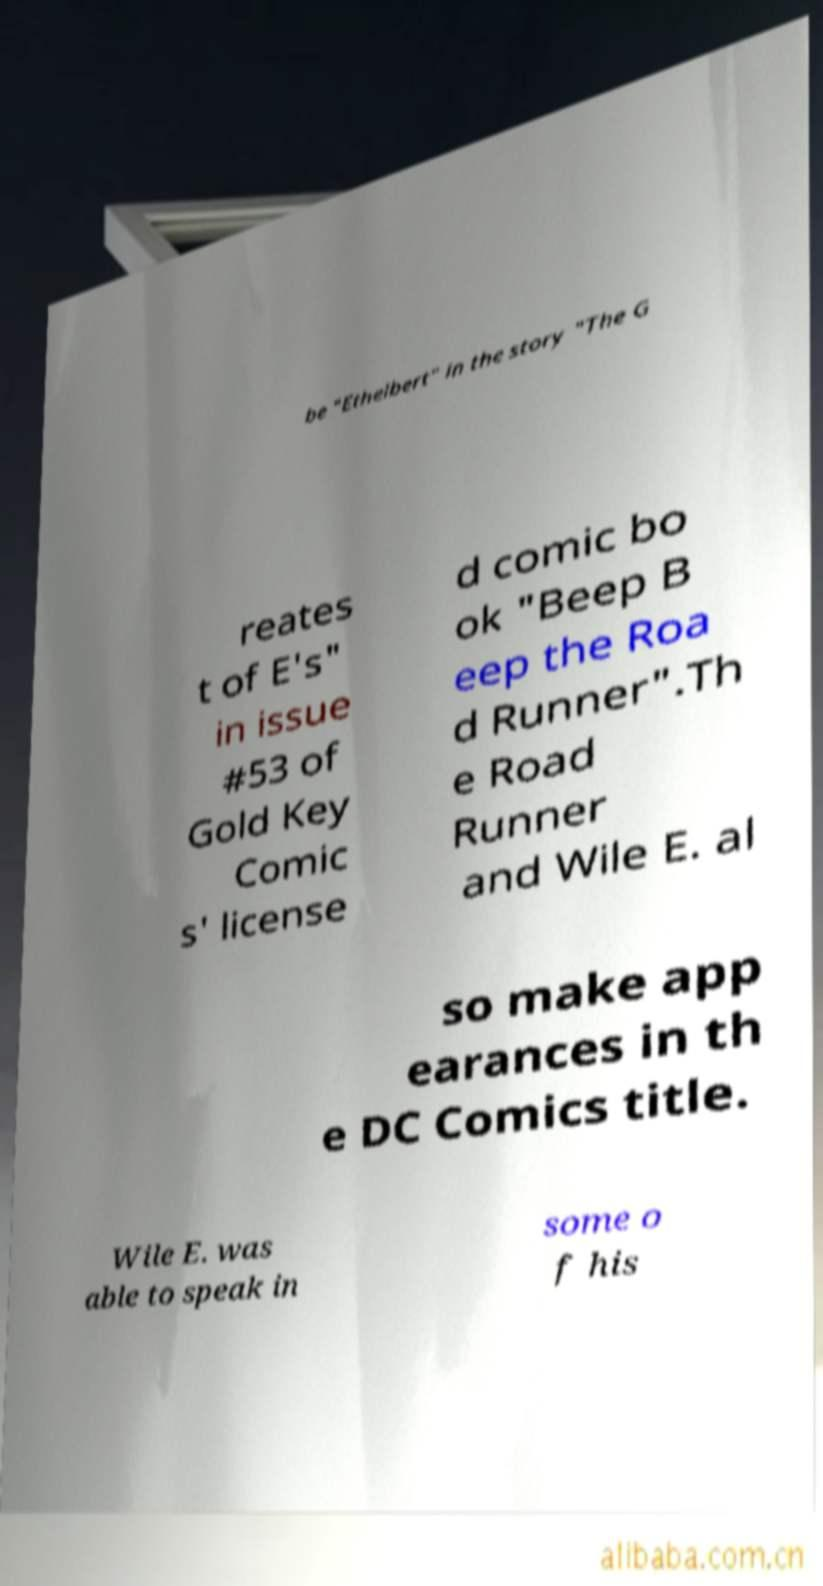Please identify and transcribe the text found in this image. be "Ethelbert" in the story "The G reates t of E's" in issue #53 of Gold Key Comic s' license d comic bo ok "Beep B eep the Roa d Runner".Th e Road Runner and Wile E. al so make app earances in th e DC Comics title. Wile E. was able to speak in some o f his 